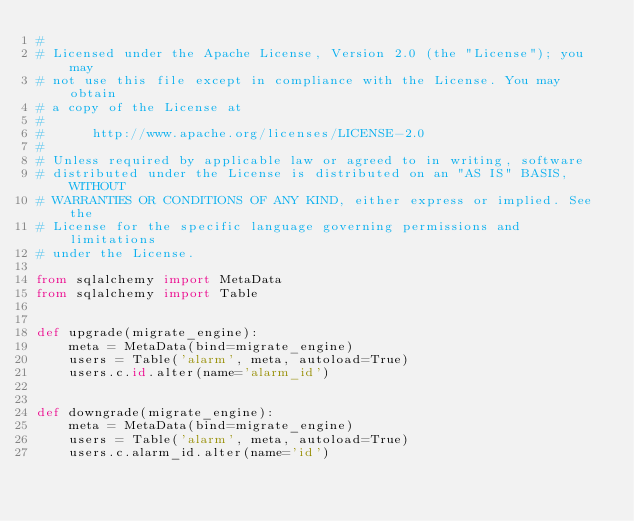<code> <loc_0><loc_0><loc_500><loc_500><_Python_>#
# Licensed under the Apache License, Version 2.0 (the "License"); you may
# not use this file except in compliance with the License. You may obtain
# a copy of the License at
#
#      http://www.apache.org/licenses/LICENSE-2.0
#
# Unless required by applicable law or agreed to in writing, software
# distributed under the License is distributed on an "AS IS" BASIS, WITHOUT
# WARRANTIES OR CONDITIONS OF ANY KIND, either express or implied. See the
# License for the specific language governing permissions and limitations
# under the License.

from sqlalchemy import MetaData
from sqlalchemy import Table


def upgrade(migrate_engine):
    meta = MetaData(bind=migrate_engine)
    users = Table('alarm', meta, autoload=True)
    users.c.id.alter(name='alarm_id')


def downgrade(migrate_engine):
    meta = MetaData(bind=migrate_engine)
    users = Table('alarm', meta, autoload=True)
    users.c.alarm_id.alter(name='id')
</code> 